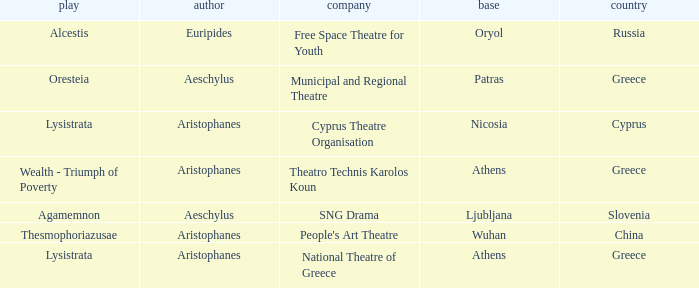What is the company when the country is greece and the author is aeschylus? Municipal and Regional Theatre. 